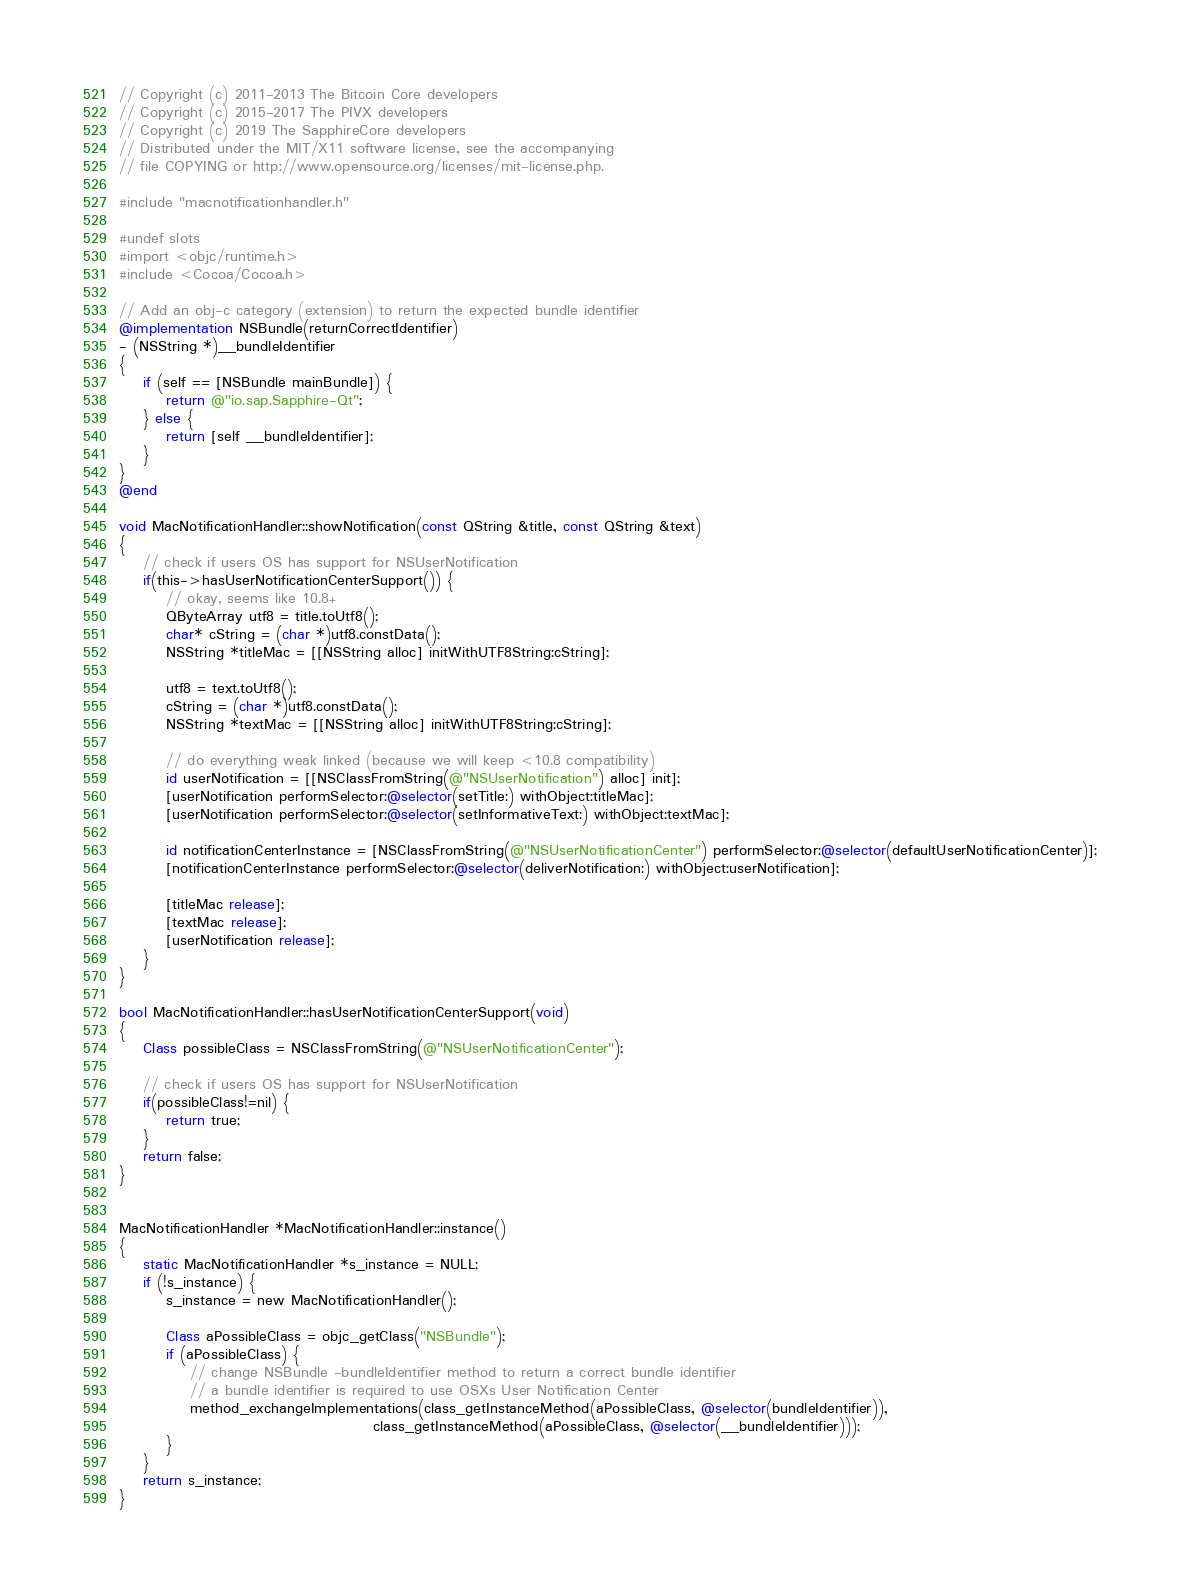Convert code to text. <code><loc_0><loc_0><loc_500><loc_500><_ObjectiveC_>// Copyright (c) 2011-2013 The Bitcoin Core developers
// Copyright (c) 2015-2017 The PIVX developers
// Copyright (c) 2019 The SapphireCore developers
// Distributed under the MIT/X11 software license, see the accompanying
// file COPYING or http://www.opensource.org/licenses/mit-license.php.

#include "macnotificationhandler.h"

#undef slots
#import <objc/runtime.h>
#include <Cocoa/Cocoa.h>

// Add an obj-c category (extension) to return the expected bundle identifier
@implementation NSBundle(returnCorrectIdentifier)
- (NSString *)__bundleIdentifier
{
    if (self == [NSBundle mainBundle]) {
        return @"io.sap.Sapphire-Qt";
    } else {
        return [self __bundleIdentifier];
    }
}
@end

void MacNotificationHandler::showNotification(const QString &title, const QString &text)
{
    // check if users OS has support for NSUserNotification
    if(this->hasUserNotificationCenterSupport()) {
        // okay, seems like 10.8+
        QByteArray utf8 = title.toUtf8();
        char* cString = (char *)utf8.constData();
        NSString *titleMac = [[NSString alloc] initWithUTF8String:cString];

        utf8 = text.toUtf8();
        cString = (char *)utf8.constData();
        NSString *textMac = [[NSString alloc] initWithUTF8String:cString];

        // do everything weak linked (because we will keep <10.8 compatibility)
        id userNotification = [[NSClassFromString(@"NSUserNotification") alloc] init];
        [userNotification performSelector:@selector(setTitle:) withObject:titleMac];
        [userNotification performSelector:@selector(setInformativeText:) withObject:textMac];

        id notificationCenterInstance = [NSClassFromString(@"NSUserNotificationCenter") performSelector:@selector(defaultUserNotificationCenter)];
        [notificationCenterInstance performSelector:@selector(deliverNotification:) withObject:userNotification];

        [titleMac release];
        [textMac release];
        [userNotification release];
    }
}

bool MacNotificationHandler::hasUserNotificationCenterSupport(void)
{
    Class possibleClass = NSClassFromString(@"NSUserNotificationCenter");

    // check if users OS has support for NSUserNotification
    if(possibleClass!=nil) {
        return true;
    }
    return false;
}


MacNotificationHandler *MacNotificationHandler::instance()
{
    static MacNotificationHandler *s_instance = NULL;
    if (!s_instance) {
        s_instance = new MacNotificationHandler();
        
        Class aPossibleClass = objc_getClass("NSBundle");
        if (aPossibleClass) {
            // change NSBundle -bundleIdentifier method to return a correct bundle identifier
            // a bundle identifier is required to use OSXs User Notification Center
            method_exchangeImplementations(class_getInstanceMethod(aPossibleClass, @selector(bundleIdentifier)),
                                           class_getInstanceMethod(aPossibleClass, @selector(__bundleIdentifier)));
        }
    }
    return s_instance;
}
</code> 